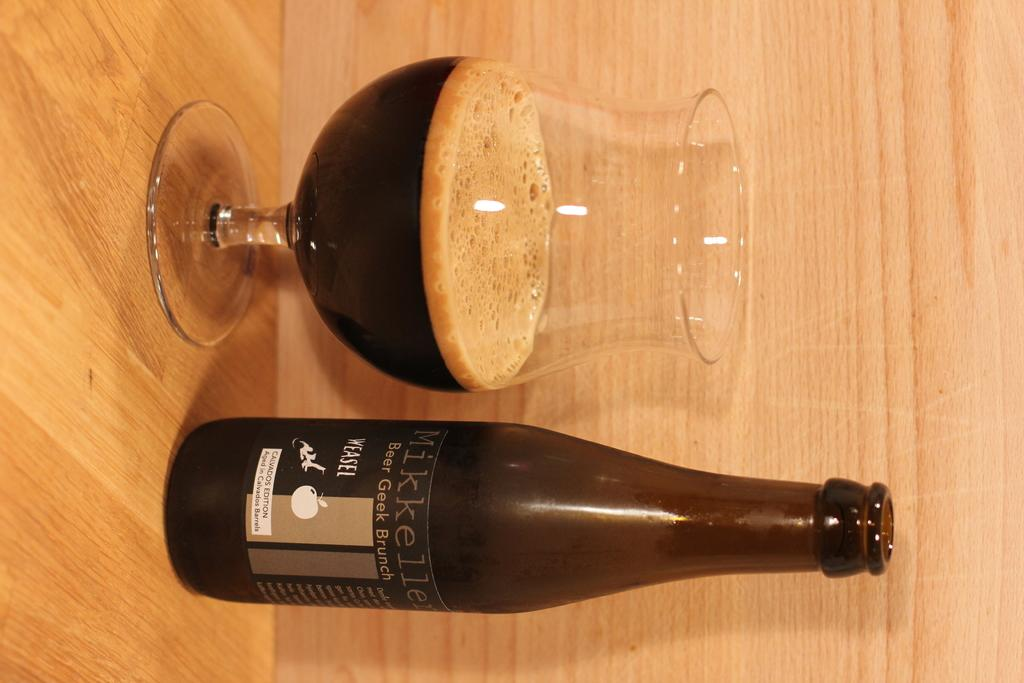<image>
Relay a brief, clear account of the picture shown. A dark colored bottle of Mikkeller is standing next to a half filled glass on a wooden shelf. 